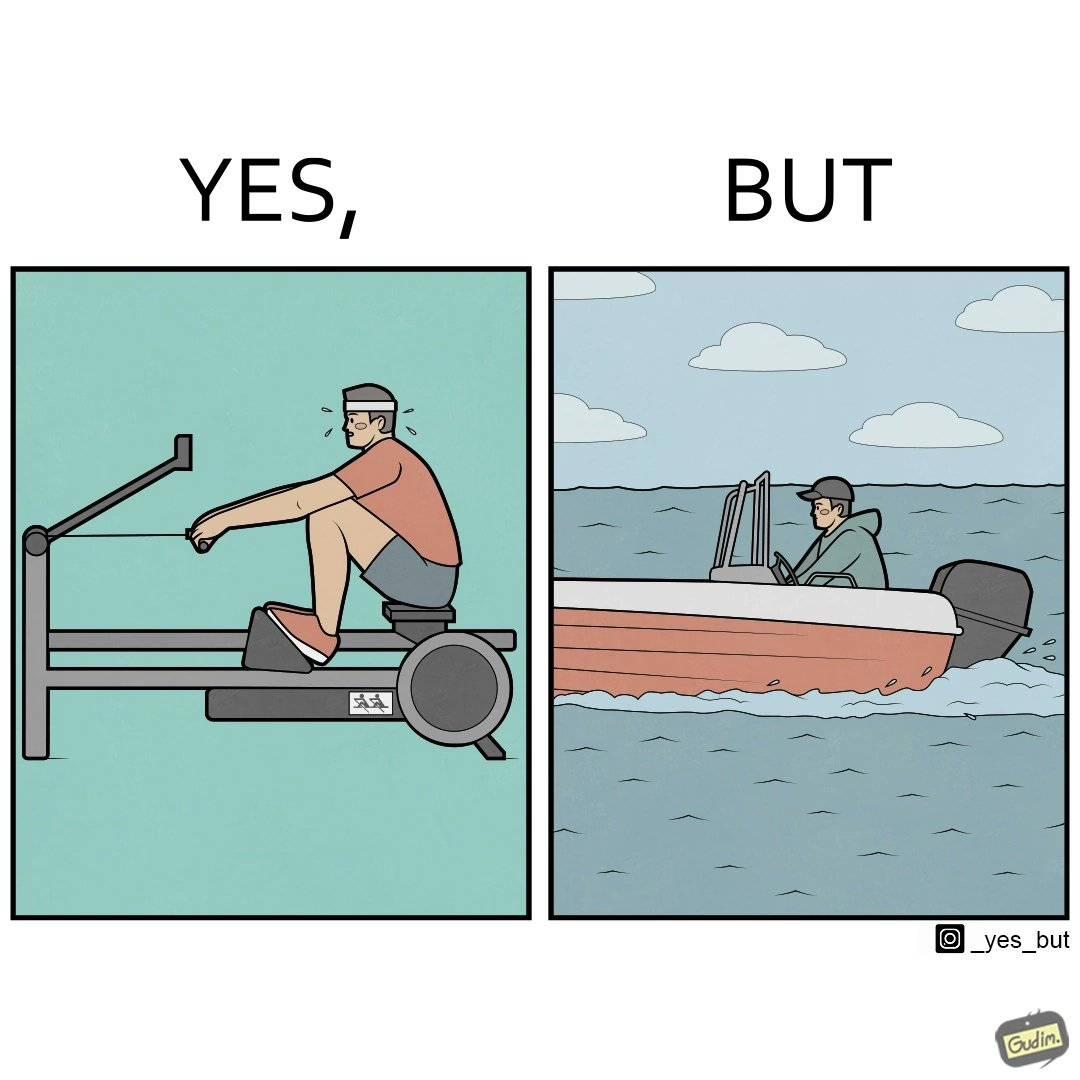Why is this image considered satirical? The image is ironic, because people often use rowing machine at the gym don't prefer rowing when it comes to boats 